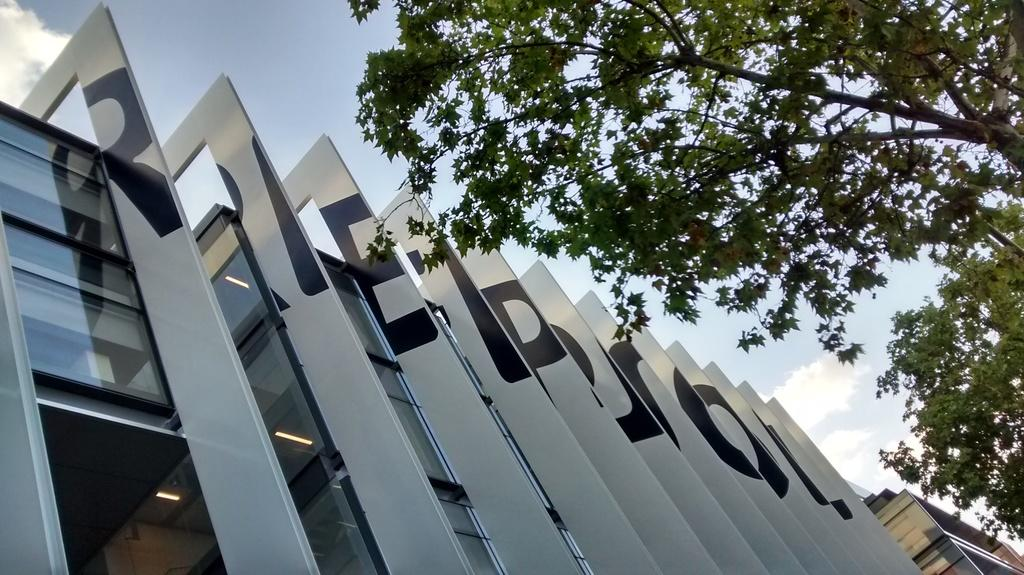What type of structures can be seen in the image? The image contains architecture of buildings. What natural elements are present in the image? There are trees visible in the image. What is visible at the top of the image? The sky is visible at the top of the image. How much money is being exchanged between the buildings in the image? There is no indication of money or any financial transaction in the image; it features buildings, trees, and the sky. 